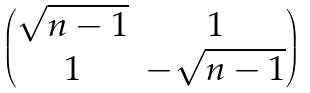Convert formula to latex. <formula><loc_0><loc_0><loc_500><loc_500>\begin{pmatrix} \sqrt { n - 1 } & 1 \\ 1 & - \sqrt { n - 1 } \end{pmatrix}</formula> 